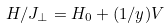<formula> <loc_0><loc_0><loc_500><loc_500>H / J _ { \perp } = H _ { 0 } + ( 1 / y ) V</formula> 